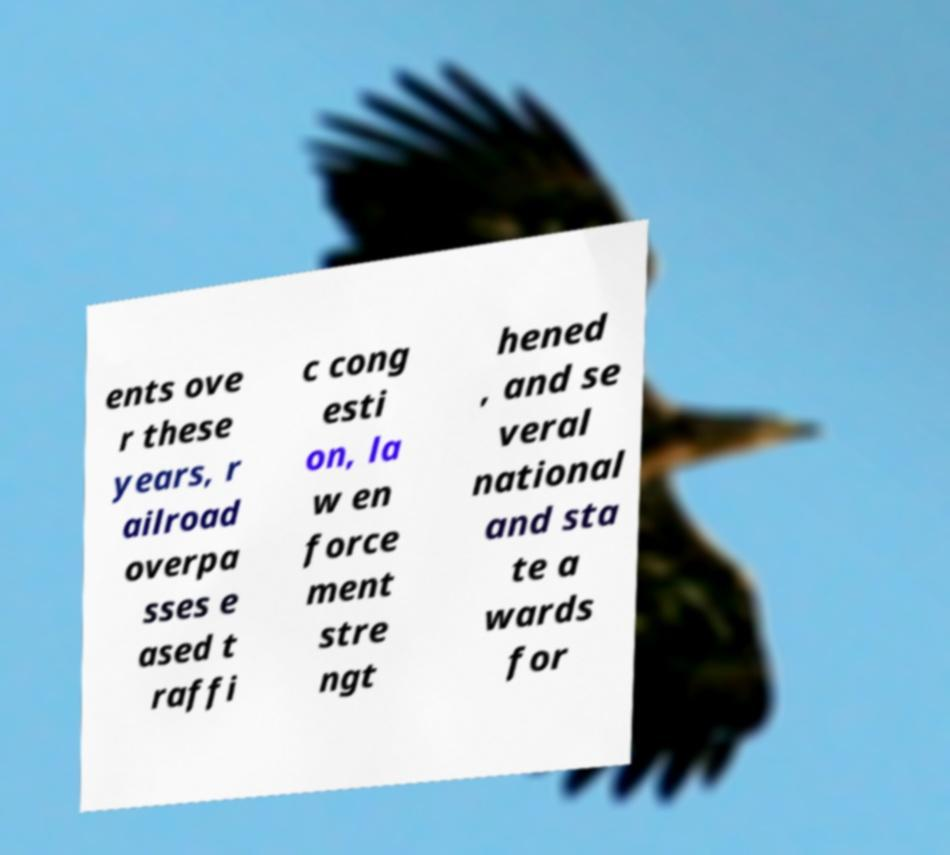Could you assist in decoding the text presented in this image and type it out clearly? ents ove r these years, r ailroad overpa sses e ased t raffi c cong esti on, la w en force ment stre ngt hened , and se veral national and sta te a wards for 